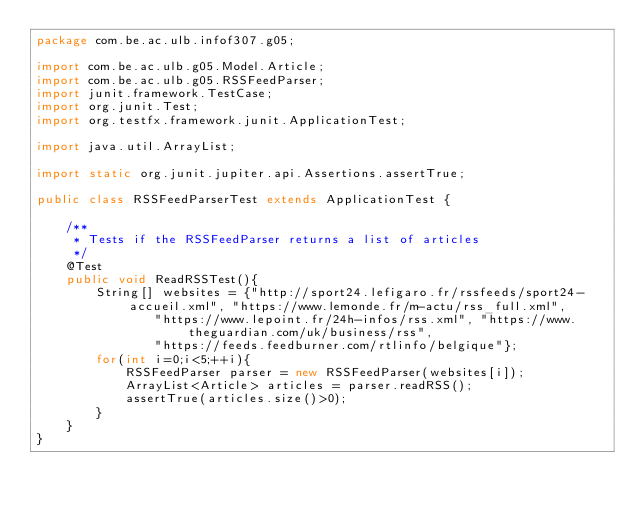Convert code to text. <code><loc_0><loc_0><loc_500><loc_500><_Java_>package com.be.ac.ulb.infof307.g05;

import com.be.ac.ulb.g05.Model.Article;
import com.be.ac.ulb.g05.RSSFeedParser;
import junit.framework.TestCase;
import org.junit.Test;
import org.testfx.framework.junit.ApplicationTest;

import java.util.ArrayList;

import static org.junit.jupiter.api.Assertions.assertTrue;

public class RSSFeedParserTest extends ApplicationTest {

    /**
     * Tests if the RSSFeedParser returns a list of articles
     */
    @Test
    public void ReadRSSTest(){
        String[] websites = {"http://sport24.lefigaro.fr/rssfeeds/sport24-accueil.xml", "https://www.lemonde.fr/m-actu/rss_full.xml",
                "https://www.lepoint.fr/24h-infos/rss.xml", "https://www.theguardian.com/uk/business/rss",
                "https://feeds.feedburner.com/rtlinfo/belgique"};
        for(int i=0;i<5;++i){
            RSSFeedParser parser = new RSSFeedParser(websites[i]);
            ArrayList<Article> articles = parser.readRSS();
            assertTrue(articles.size()>0);
        }
    }
}</code> 